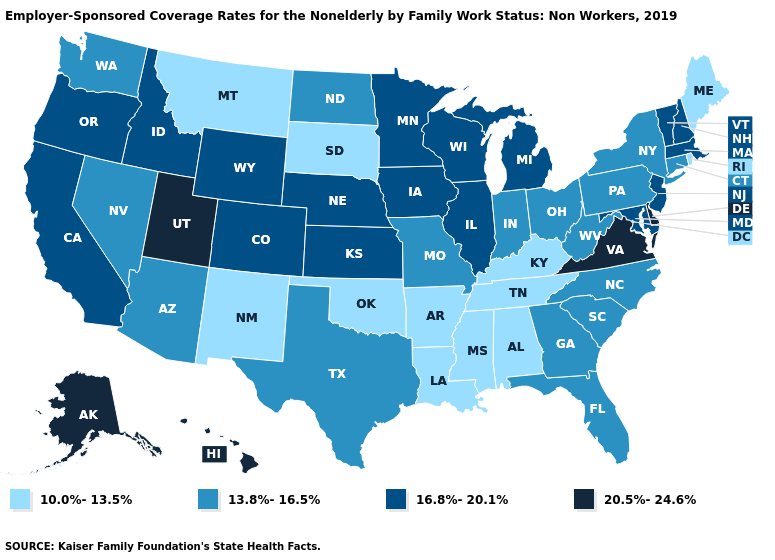Name the states that have a value in the range 16.8%-20.1%?
Answer briefly. California, Colorado, Idaho, Illinois, Iowa, Kansas, Maryland, Massachusetts, Michigan, Minnesota, Nebraska, New Hampshire, New Jersey, Oregon, Vermont, Wisconsin, Wyoming. Name the states that have a value in the range 10.0%-13.5%?
Be succinct. Alabama, Arkansas, Kentucky, Louisiana, Maine, Mississippi, Montana, New Mexico, Oklahoma, Rhode Island, South Dakota, Tennessee. What is the value of New Jersey?
Keep it brief. 16.8%-20.1%. What is the value of Massachusetts?
Quick response, please. 16.8%-20.1%. Name the states that have a value in the range 10.0%-13.5%?
Be succinct. Alabama, Arkansas, Kentucky, Louisiana, Maine, Mississippi, Montana, New Mexico, Oklahoma, Rhode Island, South Dakota, Tennessee. Name the states that have a value in the range 20.5%-24.6%?
Write a very short answer. Alaska, Delaware, Hawaii, Utah, Virginia. Name the states that have a value in the range 10.0%-13.5%?
Keep it brief. Alabama, Arkansas, Kentucky, Louisiana, Maine, Mississippi, Montana, New Mexico, Oklahoma, Rhode Island, South Dakota, Tennessee. Is the legend a continuous bar?
Answer briefly. No. What is the value of Alaska?
Concise answer only. 20.5%-24.6%. What is the highest value in the USA?
Short answer required. 20.5%-24.6%. Does the first symbol in the legend represent the smallest category?
Keep it brief. Yes. Among the states that border Utah , does Arizona have the lowest value?
Concise answer only. No. What is the value of Arkansas?
Short answer required. 10.0%-13.5%. What is the highest value in the Northeast ?
Answer briefly. 16.8%-20.1%. Does Mississippi have the lowest value in the South?
Short answer required. Yes. 